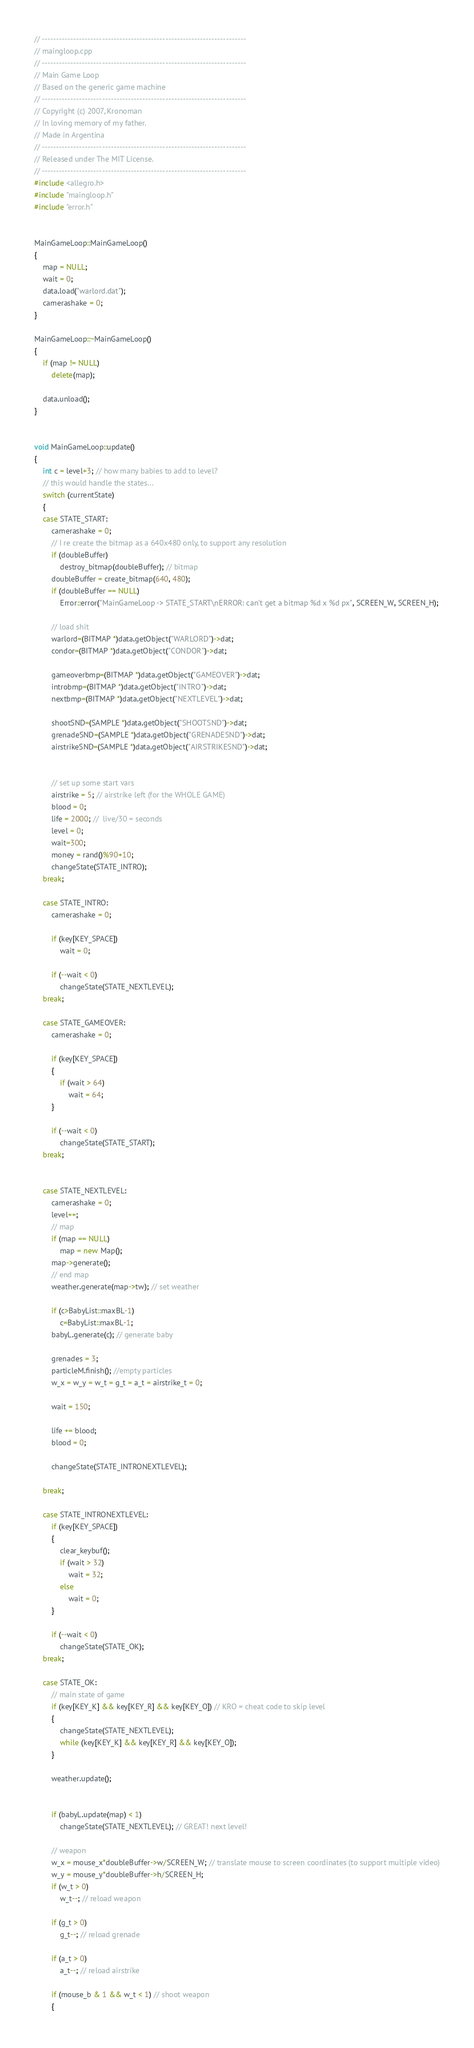Convert code to text. <code><loc_0><loc_0><loc_500><loc_500><_C++_>// -----------------------------------------------------------------------
// maingloop.cpp
// -----------------------------------------------------------------------
// Main Game Loop
// Based on the generic game machine
// -----------------------------------------------------------------------
// Copyright (c) 2007, Kronoman
// In loving memory of my father.
// Made in Argentina
// -----------------------------------------------------------------------
// Released under The MIT License.
// -----------------------------------------------------------------------
#include <allegro.h>
#include "maingloop.h"
#include "error.h"


MainGameLoop::MainGameLoop()
{
	map = NULL;
	wait = 0;
	data.load("warlord.dat");
	camerashake = 0;
}

MainGameLoop::~MainGameLoop()
{
	if (map != NULL)
		delete(map);
	
	data.unload();
}


void MainGameLoop::update()
{
	int c = level+3; // how many babies to add to level?
	// this would handle the states...
	switch (currentState)
	{
	case STATE_START:
		camerashake = 0;
		// I re create the bitmap as a 640x480 only, to support any resolution
		if (doubleBuffer)
			destroy_bitmap(doubleBuffer); // bitmap
		doubleBuffer = create_bitmap(640, 480);
		if (doubleBuffer == NULL)
			Error::error("MainGameLoop -> STATE_START\nERROR: can't get a bitmap %d x %d px", SCREEN_W, SCREEN_H);
		
		// load shit
		warlord=(BITMAP *)data.getObject("WARLORD")->dat;
		condor=(BITMAP *)data.getObject("CONDOR")->dat;
	
		gameoverbmp=(BITMAP *)data.getObject("GAMEOVER")->dat;
		introbmp=(BITMAP *)data.getObject("INTRO")->dat;
		nextbmp=(BITMAP *)data.getObject("NEXTLEVEL")->dat;

		shootSND=(SAMPLE *)data.getObject("SHOOTSND")->dat;
		grenadeSND=(SAMPLE *)data.getObject("GRENADESND")->dat;
		airstrikeSND=(SAMPLE *)data.getObject("AIRSTRIKESND")->dat;


		// set up some start vars
		airstrike = 5; // airstrike left (for the WHOLE GAME)
		blood = 0;
		life = 2000; //  live/30 = seconds
		level = 0;
		wait=300;
		money = rand()%90+10;
		changeState(STATE_INTRO);
	break;

	case STATE_INTRO:
		camerashake = 0;

		if (key[KEY_SPACE])
			wait = 0;

		if (--wait < 0)
			changeState(STATE_NEXTLEVEL);
	break;

	case STATE_GAMEOVER:
		camerashake = 0;

		if (key[KEY_SPACE])
		{
			if (wait > 64)
				wait = 64;
		}

		if (--wait < 0)
			changeState(STATE_START);
	break;


	case STATE_NEXTLEVEL:
		camerashake = 0;
		level++;
		// map
		if (map == NULL)
			map = new Map();
		map->generate();
		// end map
		weather.generate(map->tw); // set weather

		if (c>BabyList::maxBL-1)
			c=BabyList::maxBL-1;
		babyL.generate(c); // generate baby

		grenades = 3;
		particleM.finish(); //empty particles
		w_x = w_y = w_t = g_t = a_t = airstrike_t = 0;

		wait = 150;
		
		life += blood;
		blood = 0;

		changeState(STATE_INTRONEXTLEVEL);

	break;

	case STATE_INTRONEXTLEVEL:		
		if (key[KEY_SPACE])
		{
			clear_keybuf();
			if (wait > 32)
				wait = 32;
			else
				wait = 0;
		}

		if (--wait < 0)
			changeState(STATE_OK);
	break;

	case STATE_OK:
		// main state of game		
		if (key[KEY_K] && key[KEY_R] && key[KEY_O]) // KRO = cheat code to skip level
		{
			changeState(STATE_NEXTLEVEL);
			while (key[KEY_K] && key[KEY_R] && key[KEY_O]);
		}

		weather.update();


		if (babyL.update(map) < 1)
			changeState(STATE_NEXTLEVEL); // GREAT! next level!

		// weapon
		w_x = mouse_x*doubleBuffer->w/SCREEN_W; // translate mouse to screen coordinates (to support multiple video)
		w_y = mouse_y*doubleBuffer->h/SCREEN_H;
		if (w_t > 0)
			w_t--; // reload weapon

		if (g_t > 0)
			g_t--; // reload grenade

		if (a_t > 0)
			a_t--; // reload airstrike

		if (mouse_b & 1 && w_t < 1) // shoot weapon
		{</code> 